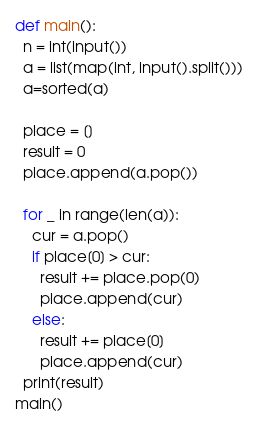<code> <loc_0><loc_0><loc_500><loc_500><_Python_>def main():
  n = int(input())
  a = list(map(int, input().split()))
  a=sorted(a)
  
  place = []
  result = 0
  place.append(a.pop())
  
  for _ in range(len(a)):
    cur = a.pop()
    if place[0] > cur:
      result += place.pop(0)
      place.append(cur)
    else:
      result += place[0]
      place.append(cur)
  print(result)
main()</code> 